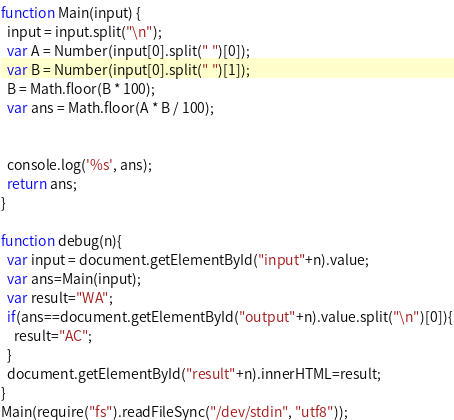<code> <loc_0><loc_0><loc_500><loc_500><_JavaScript_>function Main(input) {
  input = input.split("\n");
  var A = Number(input[0].split(" ")[0]);
  var B = Number(input[0].split(" ")[1]);
  B = Math.floor(B * 100);
  var ans = Math.floor(A * B / 100);


  console.log('%s', ans);
  return ans;
}

function debug(n){
  var input = document.getElementById("input"+n).value;
  var ans=Main(input);
  var result="WA";
  if(ans==document.getElementById("output"+n).value.split("\n")[0]){
    result="AC";
  }
  document.getElementById("result"+n).innerHTML=result;
}
Main(require("fs").readFileSync("/dev/stdin", "utf8"));
</code> 